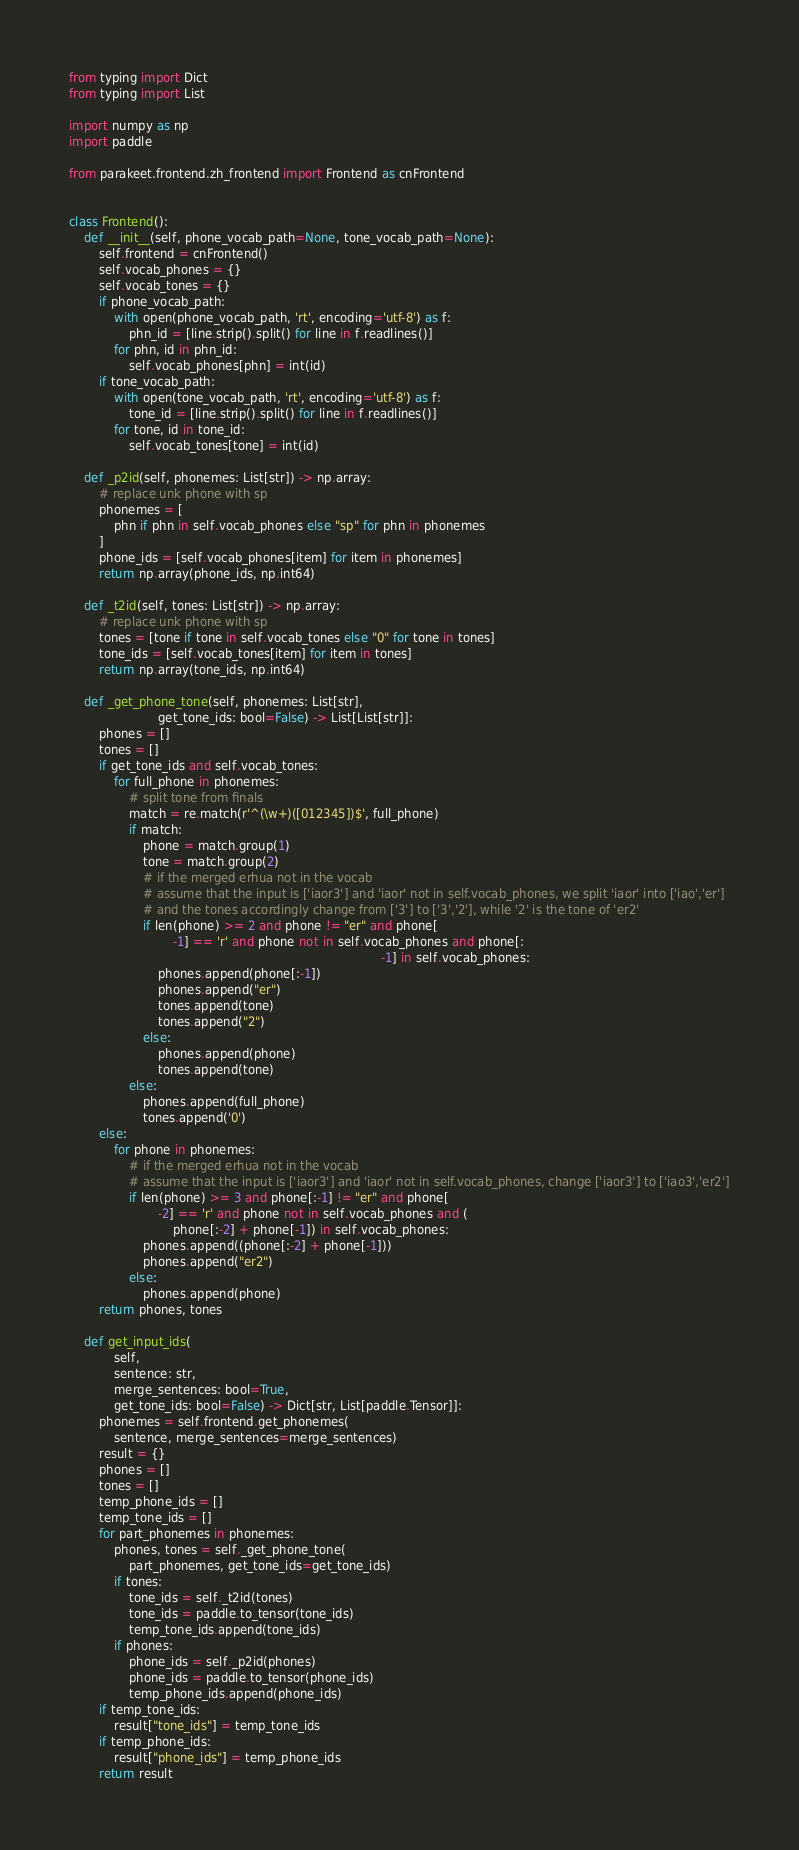<code> <loc_0><loc_0><loc_500><loc_500><_Python_>from typing import Dict
from typing import List

import numpy as np
import paddle

from parakeet.frontend.zh_frontend import Frontend as cnFrontend


class Frontend():
    def __init__(self, phone_vocab_path=None, tone_vocab_path=None):
        self.frontend = cnFrontend()
        self.vocab_phones = {}
        self.vocab_tones = {}
        if phone_vocab_path:
            with open(phone_vocab_path, 'rt', encoding='utf-8') as f:
                phn_id = [line.strip().split() for line in f.readlines()]
            for phn, id in phn_id:
                self.vocab_phones[phn] = int(id)
        if tone_vocab_path:
            with open(tone_vocab_path, 'rt', encoding='utf-8') as f:
                tone_id = [line.strip().split() for line in f.readlines()]
            for tone, id in tone_id:
                self.vocab_tones[tone] = int(id)

    def _p2id(self, phonemes: List[str]) -> np.array:
        # replace unk phone with sp
        phonemes = [
            phn if phn in self.vocab_phones else "sp" for phn in phonemes
        ]
        phone_ids = [self.vocab_phones[item] for item in phonemes]
        return np.array(phone_ids, np.int64)

    def _t2id(self, tones: List[str]) -> np.array:
        # replace unk phone with sp
        tones = [tone if tone in self.vocab_tones else "0" for tone in tones]
        tone_ids = [self.vocab_tones[item] for item in tones]
        return np.array(tone_ids, np.int64)

    def _get_phone_tone(self, phonemes: List[str],
                        get_tone_ids: bool=False) -> List[List[str]]:
        phones = []
        tones = []
        if get_tone_ids and self.vocab_tones:
            for full_phone in phonemes:
                # split tone from finals
                match = re.match(r'^(\w+)([012345])$', full_phone)
                if match:
                    phone = match.group(1)
                    tone = match.group(2)
                    # if the merged erhua not in the vocab
                    # assume that the input is ['iaor3'] and 'iaor' not in self.vocab_phones, we split 'iaor' into ['iao','er']
                    # and the tones accordingly change from ['3'] to ['3','2'], while '2' is the tone of 'er2'
                    if len(phone) >= 2 and phone != "er" and phone[
                            -1] == 'r' and phone not in self.vocab_phones and phone[:
                                                                                    -1] in self.vocab_phones:
                        phones.append(phone[:-1])
                        phones.append("er")
                        tones.append(tone)
                        tones.append("2")
                    else:
                        phones.append(phone)
                        tones.append(tone)
                else:
                    phones.append(full_phone)
                    tones.append('0')
        else:
            for phone in phonemes:
                # if the merged erhua not in the vocab
                # assume that the input is ['iaor3'] and 'iaor' not in self.vocab_phones, change ['iaor3'] to ['iao3','er2']
                if len(phone) >= 3 and phone[:-1] != "er" and phone[
                        -2] == 'r' and phone not in self.vocab_phones and (
                            phone[:-2] + phone[-1]) in self.vocab_phones:
                    phones.append((phone[:-2] + phone[-1]))
                    phones.append("er2")
                else:
                    phones.append(phone)
        return phones, tones

    def get_input_ids(
            self,
            sentence: str,
            merge_sentences: bool=True,
            get_tone_ids: bool=False) -> Dict[str, List[paddle.Tensor]]:
        phonemes = self.frontend.get_phonemes(
            sentence, merge_sentences=merge_sentences)
        result = {}
        phones = []
        tones = []
        temp_phone_ids = []
        temp_tone_ids = []
        for part_phonemes in phonemes:
            phones, tones = self._get_phone_tone(
                part_phonemes, get_tone_ids=get_tone_ids)
            if tones:
                tone_ids = self._t2id(tones)
                tone_ids = paddle.to_tensor(tone_ids)
                temp_tone_ids.append(tone_ids)
            if phones:
                phone_ids = self._p2id(phones)
                phone_ids = paddle.to_tensor(phone_ids)
                temp_phone_ids.append(phone_ids)
        if temp_tone_ids:
            result["tone_ids"] = temp_tone_ids
        if temp_phone_ids:
            result["phone_ids"] = temp_phone_ids
        return result
</code> 